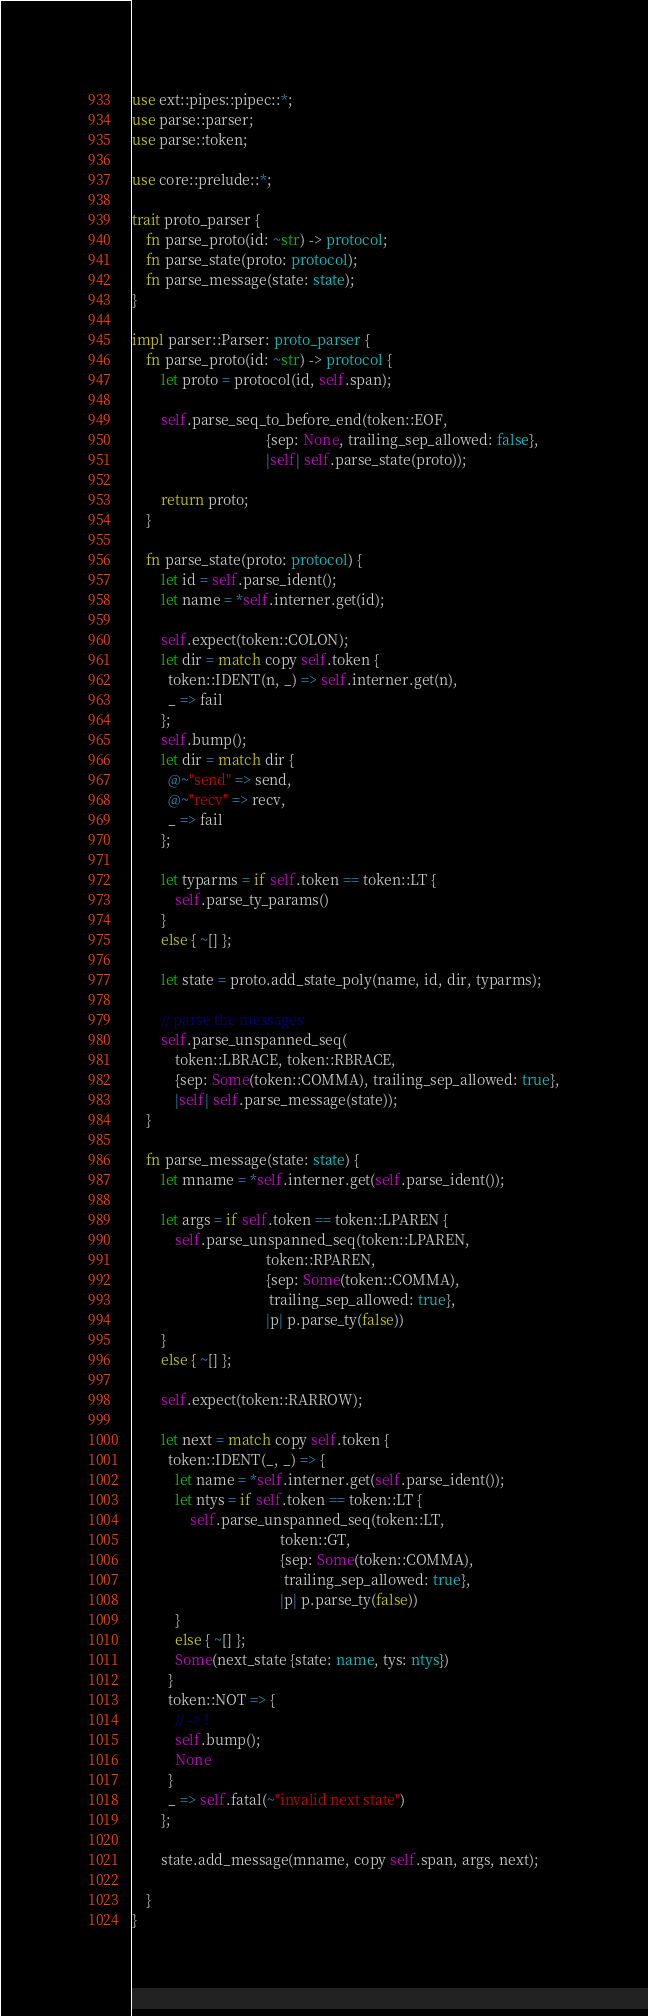Convert code to text. <code><loc_0><loc_0><loc_500><loc_500><_Rust_>use ext::pipes::pipec::*;
use parse::parser;
use parse::token;

use core::prelude::*;

trait proto_parser {
    fn parse_proto(id: ~str) -> protocol;
    fn parse_state(proto: protocol);
    fn parse_message(state: state);
}

impl parser::Parser: proto_parser {
    fn parse_proto(id: ~str) -> protocol {
        let proto = protocol(id, self.span);

        self.parse_seq_to_before_end(token::EOF,
                                     {sep: None, trailing_sep_allowed: false},
                                     |self| self.parse_state(proto));

        return proto;
    }

    fn parse_state(proto: protocol) {
        let id = self.parse_ident();
        let name = *self.interner.get(id);

        self.expect(token::COLON);
        let dir = match copy self.token {
          token::IDENT(n, _) => self.interner.get(n),
          _ => fail
        };
        self.bump();
        let dir = match dir {
          @~"send" => send,
          @~"recv" => recv,
          _ => fail
        };

        let typarms = if self.token == token::LT {
            self.parse_ty_params()
        }
        else { ~[] };

        let state = proto.add_state_poly(name, id, dir, typarms);

        // parse the messages
        self.parse_unspanned_seq(
            token::LBRACE, token::RBRACE,
            {sep: Some(token::COMMA), trailing_sep_allowed: true},
            |self| self.parse_message(state));
    }

    fn parse_message(state: state) {
        let mname = *self.interner.get(self.parse_ident());

        let args = if self.token == token::LPAREN {
            self.parse_unspanned_seq(token::LPAREN,
                                     token::RPAREN,
                                     {sep: Some(token::COMMA),
                                      trailing_sep_allowed: true},
                                     |p| p.parse_ty(false))
        }
        else { ~[] };

        self.expect(token::RARROW);

        let next = match copy self.token {
          token::IDENT(_, _) => {
            let name = *self.interner.get(self.parse_ident());
            let ntys = if self.token == token::LT {
                self.parse_unspanned_seq(token::LT,
                                         token::GT,
                                         {sep: Some(token::COMMA),
                                          trailing_sep_allowed: true},
                                         |p| p.parse_ty(false))
            }
            else { ~[] };
            Some(next_state {state: name, tys: ntys})
          }
          token::NOT => {
            // -> !
            self.bump();
            None
          }
          _ => self.fatal(~"invalid next state")
        };

        state.add_message(mname, copy self.span, args, next);

    }
}
</code> 